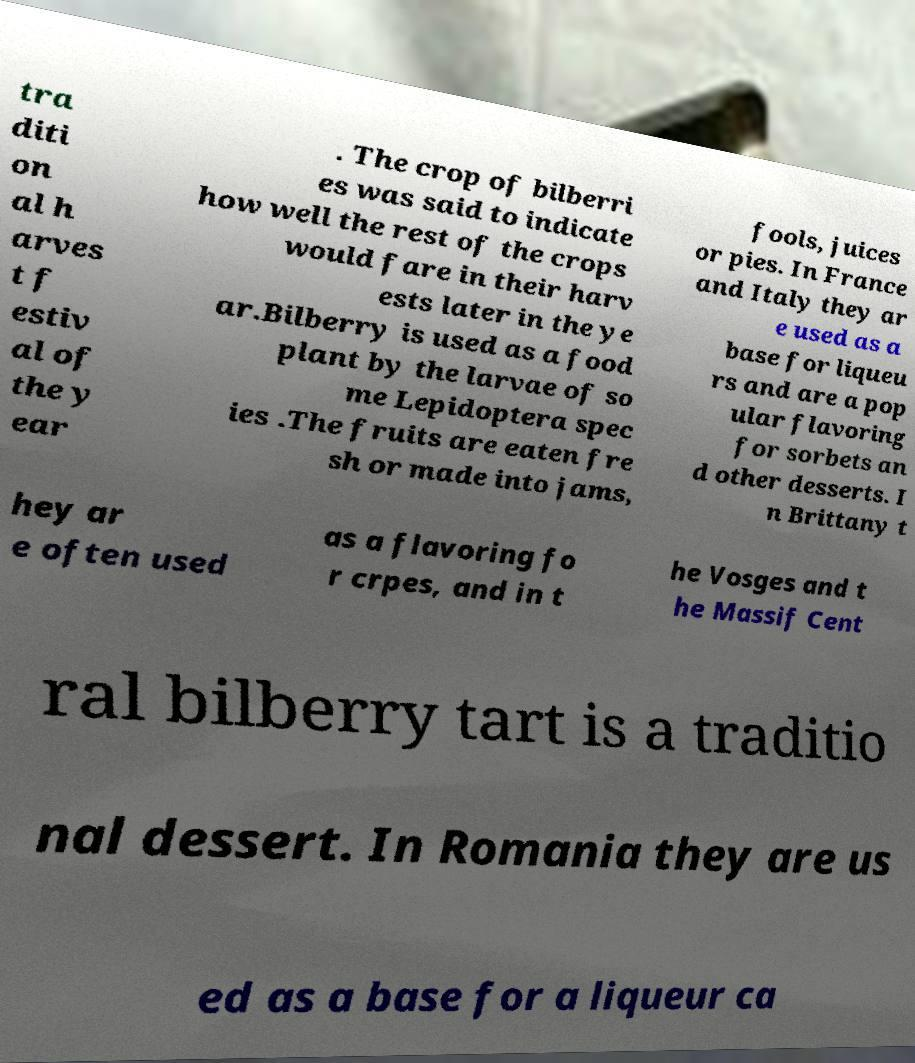Can you accurately transcribe the text from the provided image for me? tra diti on al h arves t f estiv al of the y ear . The crop of bilberri es was said to indicate how well the rest of the crops would fare in their harv ests later in the ye ar.Bilberry is used as a food plant by the larvae of so me Lepidoptera spec ies .The fruits are eaten fre sh or made into jams, fools, juices or pies. In France and Italy they ar e used as a base for liqueu rs and are a pop ular flavoring for sorbets an d other desserts. I n Brittany t hey ar e often used as a flavoring fo r crpes, and in t he Vosges and t he Massif Cent ral bilberry tart is a traditio nal dessert. In Romania they are us ed as a base for a liqueur ca 